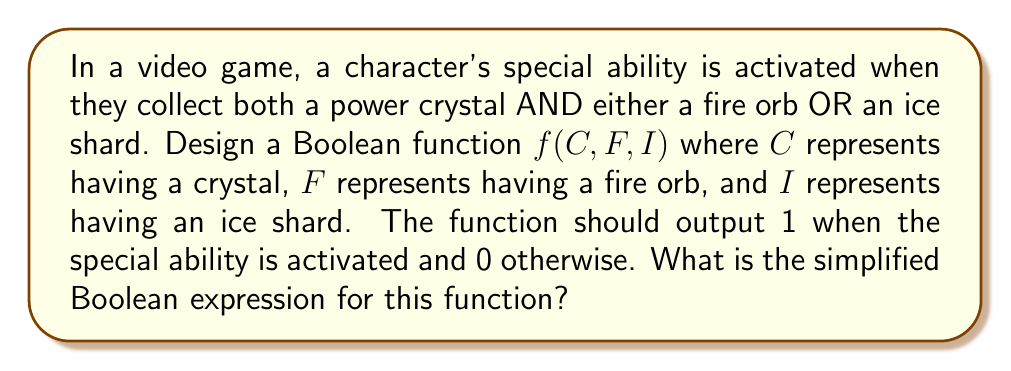Show me your answer to this math problem. Let's approach this step-by-step:

1) First, we need to translate the given conditions into a Boolean expression:
   - The character needs a crystal AND (fire orb OR ice shard)
   - In Boolean algebra, this can be written as: $C \cdot (F + I)$

2) We can expand this expression using the distributive property:
   $C \cdot (F + I) = C \cdot F + C \cdot I$

3) This expanded form $C \cdot F + C \cdot I$ is already in its simplest form, known as the sum of products (SOP) form.

4) We can verify this using a truth table:

   $$
   \begin{array}{|c|c|c|c|}
   \hline
   C & F & I & f(C,F,I) \\
   \hline
   0 & 0 & 0 & 0 \\
   0 & 0 & 1 & 0 \\
   0 & 1 & 0 & 0 \\
   0 & 1 & 1 & 0 \\
   1 & 0 & 0 & 0 \\
   1 & 0 & 1 & 1 \\
   1 & 1 & 0 & 1 \\
   1 & 1 & 1 & 1 \\
   \hline
   \end{array}
   $$

5) The truth table confirms that our function $f(C,F,I) = C \cdot F + C \cdot I$ correctly represents the desired behavior.

Therefore, the simplified Boolean expression for this function is $C \cdot F + C \cdot I$.
Answer: $C \cdot F + C \cdot I$ 